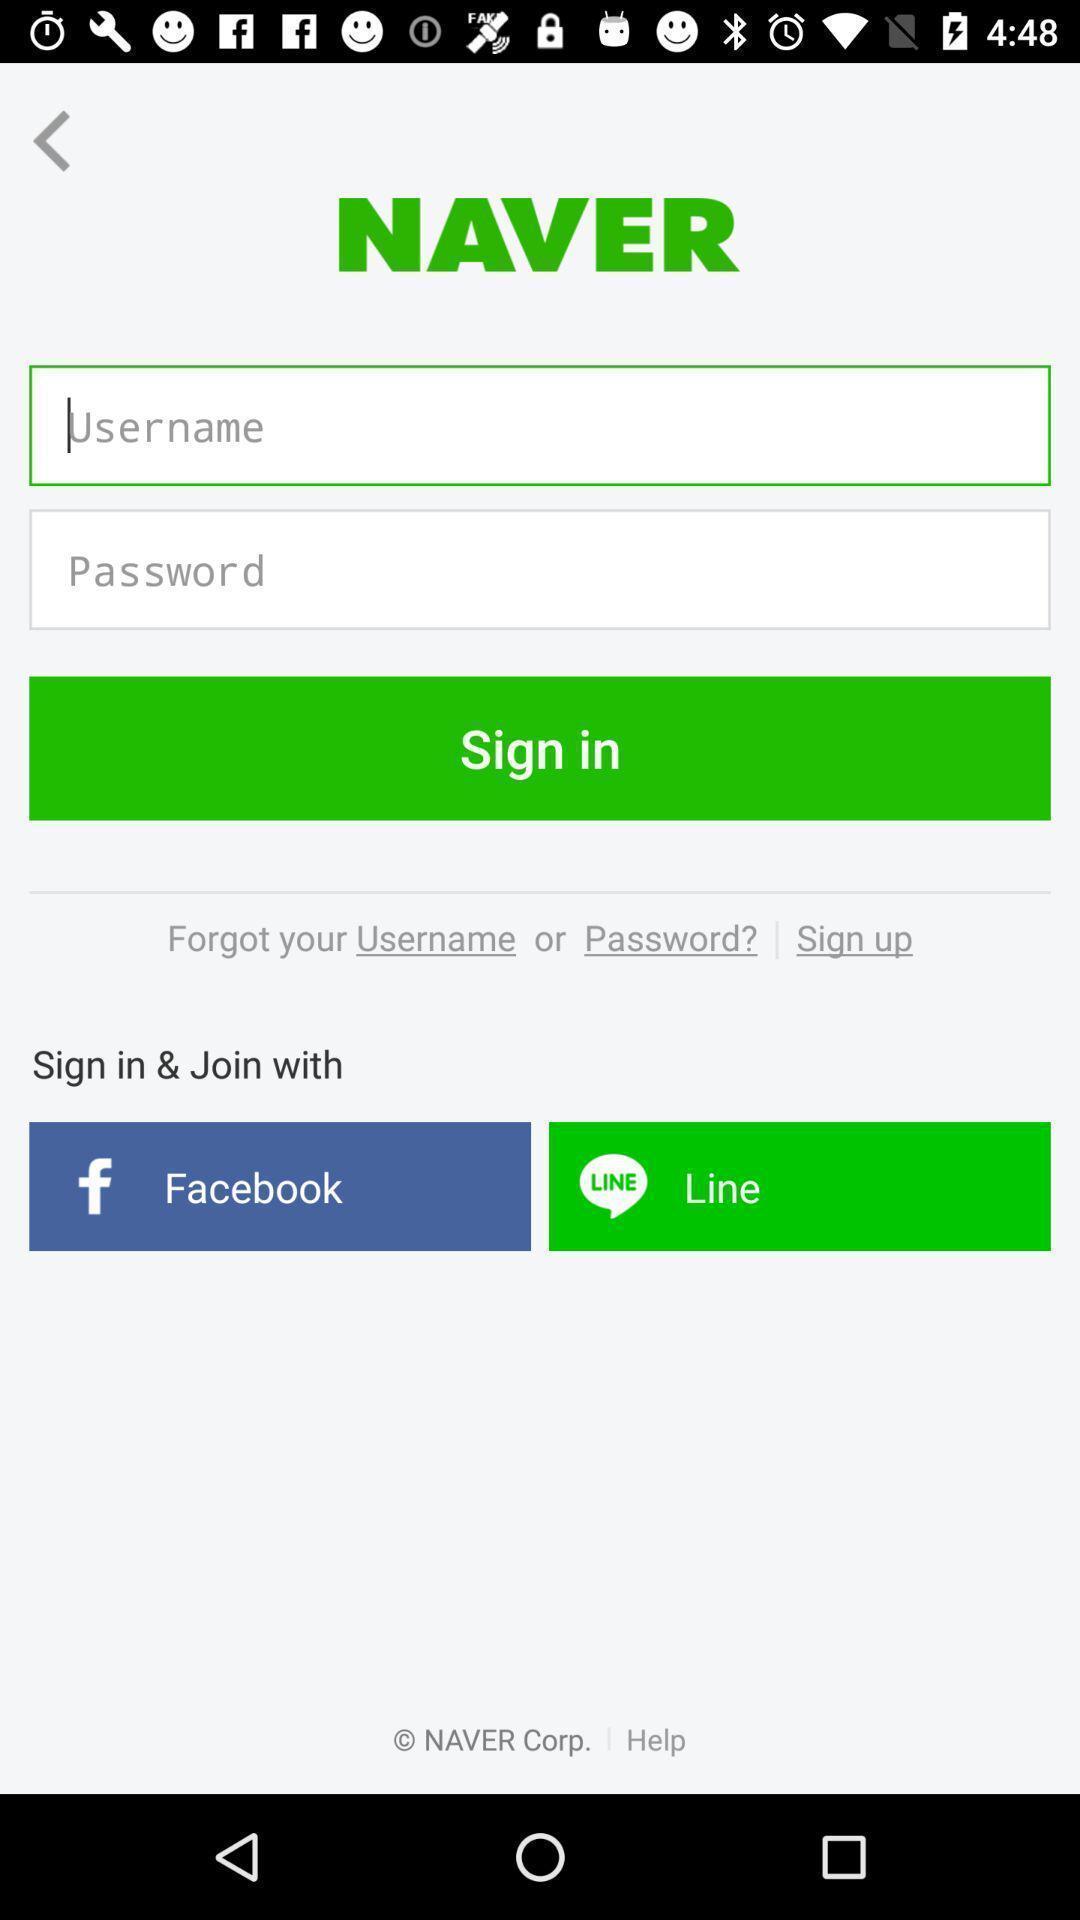Explain what's happening in this screen capture. Welcome to the login page. 